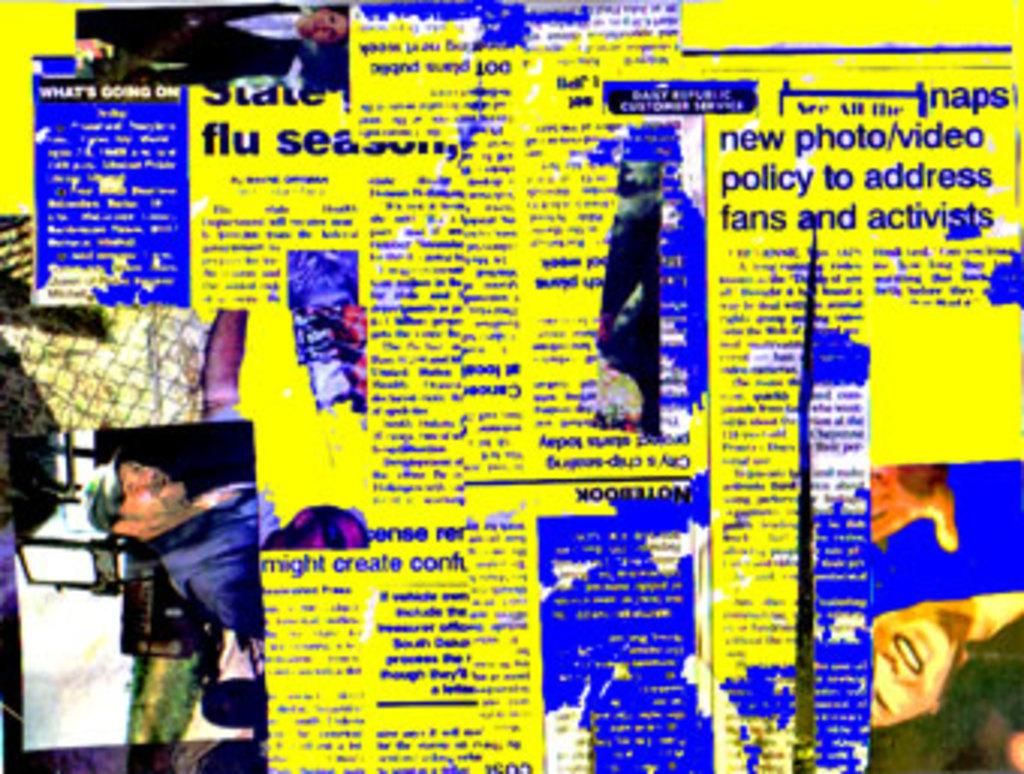What can be found in the image besides the two members on the left side? There is some text in the image. What color is the background of the image? The background of the image is yellow. How many bats are hanging from the ceiling in the image? There are no bats present in the image. What type of store can be seen in the background of the image? There is no store visible in the image; the background is yellow. 